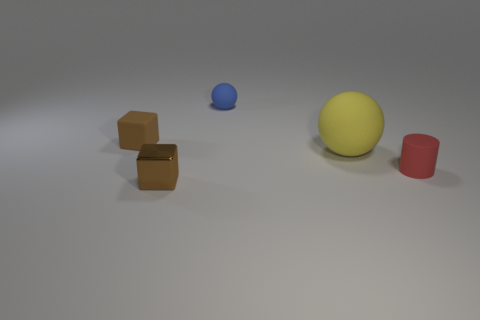What size is the yellow rubber sphere?
Give a very brief answer. Large. Do the small metal object and the matte cylinder have the same color?
Make the answer very short. No. There is a object that is to the right of the large yellow rubber ball; how big is it?
Your answer should be very brief. Small. There is a object that is in front of the red thing; is its color the same as the object behind the brown matte block?
Your response must be concise. No. How many other things are there of the same shape as the big yellow matte object?
Give a very brief answer. 1. Is the number of tiny red cylinders in front of the blue ball the same as the number of blocks in front of the large yellow ball?
Provide a short and direct response. Yes. Is the sphere that is on the right side of the small blue rubber ball made of the same material as the tiny brown block that is in front of the big yellow object?
Your response must be concise. No. How many other objects are there of the same size as the metallic block?
Your answer should be compact. 3. How many objects are either large rubber things or small objects behind the metal thing?
Your answer should be compact. 4. Are there the same number of big rubber things that are in front of the metal block and tiny gray shiny cubes?
Ensure brevity in your answer.  Yes. 